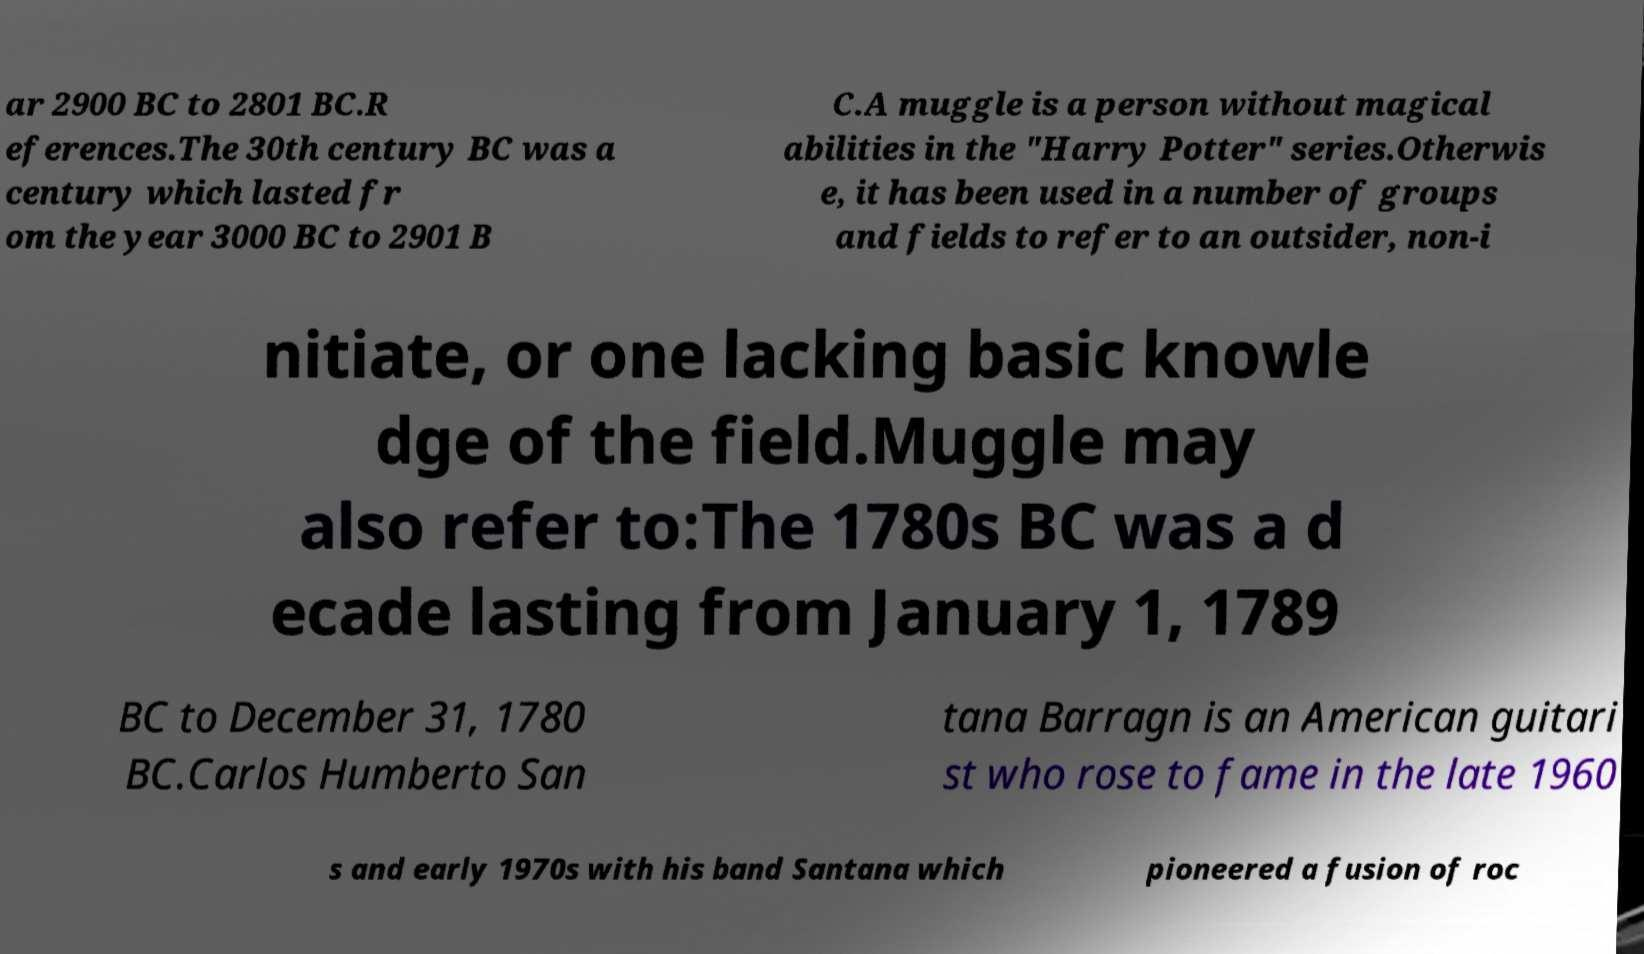What messages or text are displayed in this image? I need them in a readable, typed format. ar 2900 BC to 2801 BC.R eferences.The 30th century BC was a century which lasted fr om the year 3000 BC to 2901 B C.A muggle is a person without magical abilities in the "Harry Potter" series.Otherwis e, it has been used in a number of groups and fields to refer to an outsider, non-i nitiate, or one lacking basic knowle dge of the field.Muggle may also refer to:The 1780s BC was a d ecade lasting from January 1, 1789 BC to December 31, 1780 BC.Carlos Humberto San tana Barragn is an American guitari st who rose to fame in the late 1960 s and early 1970s with his band Santana which pioneered a fusion of roc 